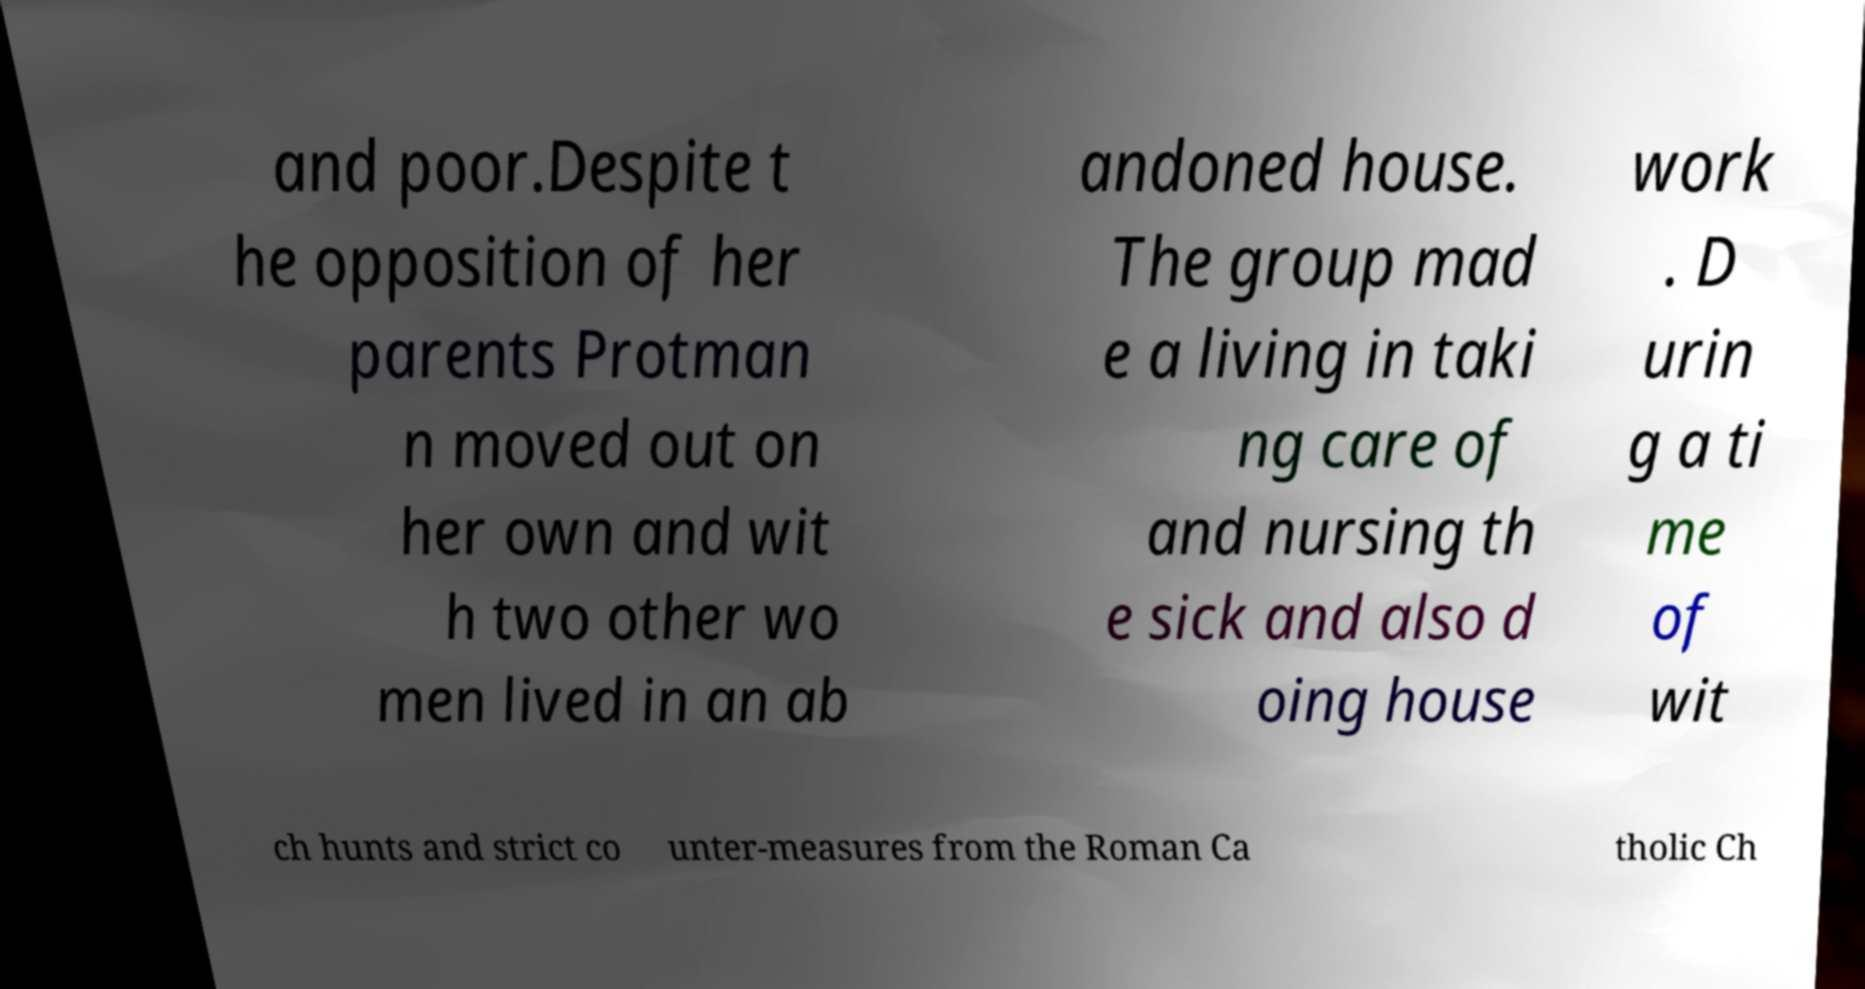Could you assist in decoding the text presented in this image and type it out clearly? and poor.Despite t he opposition of her parents Protman n moved out on her own and wit h two other wo men lived in an ab andoned house. The group mad e a living in taki ng care of and nursing th e sick and also d oing house work . D urin g a ti me of wit ch hunts and strict co unter-measures from the Roman Ca tholic Ch 